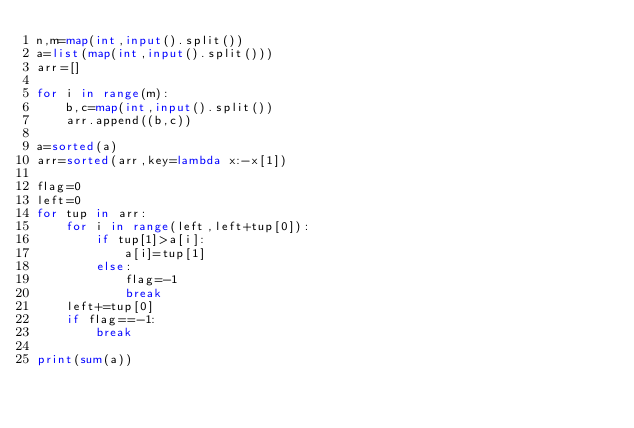<code> <loc_0><loc_0><loc_500><loc_500><_Python_>n,m=map(int,input().split())
a=list(map(int,input().split()))
arr=[]

for i in range(m):
    b,c=map(int,input().split())
    arr.append((b,c))

a=sorted(a)
arr=sorted(arr,key=lambda x:-x[1])

flag=0
left=0
for tup in arr:
    for i in range(left,left+tup[0]):
        if tup[1]>a[i]:
            a[i]=tup[1]
        else:
            flag=-1
            break
    left+=tup[0]
    if flag==-1:
        break

print(sum(a))</code> 